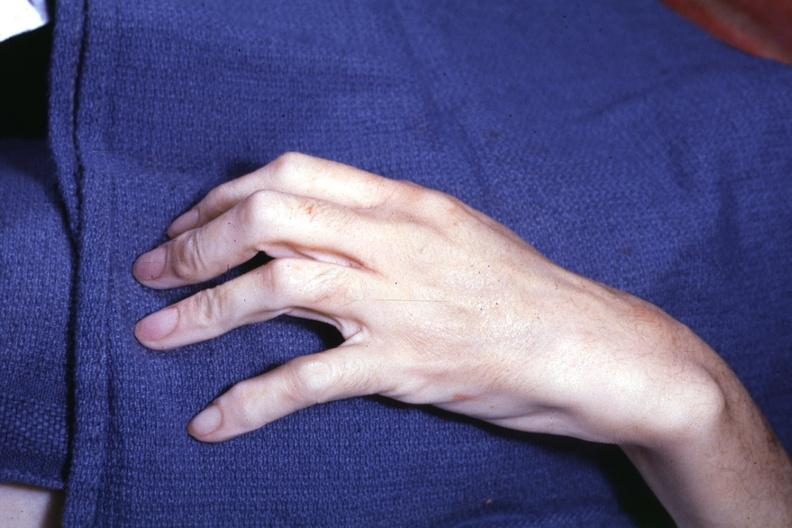what does interesting case see?
Answer the question using a single word or phrase. Other slides 